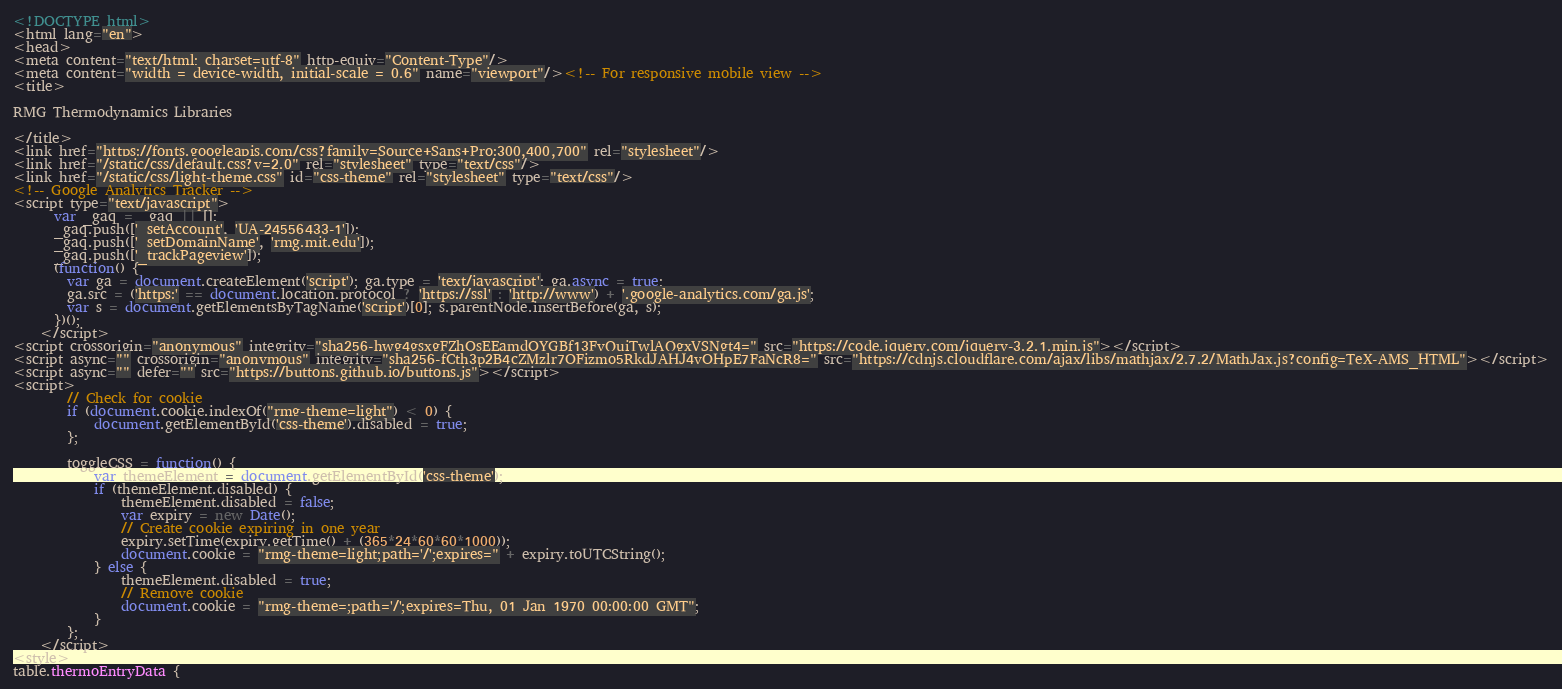<code> <loc_0><loc_0><loc_500><loc_500><_HTML_><!DOCTYPE html>
<html lang="en">
<head>
<meta content="text/html; charset=utf-8" http-equiv="Content-Type"/>
<meta content="width = device-width, initial-scale = 0.6" name="viewport"/><!-- For responsive mobile view -->
<title>

RMG Thermodynamics Libraries

</title>
<link href="https://fonts.googleapis.com/css?family=Source+Sans+Pro:300,400,700" rel="stylesheet"/>
<link href="/static/css/default.css?v=2.0" rel="stylesheet" type="text/css"/>
<link href="/static/css/light-theme.css" id="css-theme" rel="stylesheet" type="text/css"/>
<!-- Google Analytics Tracker -->
<script type="text/javascript">
      var _gaq = _gaq || [];
      _gaq.push(['_setAccount', 'UA-24556433-1']);
      _gaq.push(['_setDomainName', 'rmg.mit.edu']);
      _gaq.push(['_trackPageview']);
      (function() {
        var ga = document.createElement('script'); ga.type = 'text/javascript'; ga.async = true;
        ga.src = ('https:' == document.location.protocol ? 'https://ssl' : 'http://www') + '.google-analytics.com/ga.js';
        var s = document.getElementsByTagName('script')[0]; s.parentNode.insertBefore(ga, s);
      })();
    </script>
<script crossorigin="anonymous" integrity="sha256-hwg4gsxgFZhOsEEamdOYGBf13FyQuiTwlAQgxVSNgt4=" src="https://code.jquery.com/jquery-3.2.1.min.js"></script>
<script async="" crossorigin="anonymous" integrity="sha256-fCth3p2B4cZMzlr7OFizmo5RkdJAHJ4vOHpE7FaNcR8=" src="https://cdnjs.cloudflare.com/ajax/libs/mathjax/2.7.2/MathJax.js?config=TeX-AMS_HTML"></script>
<script async="" defer="" src="https://buttons.github.io/buttons.js"></script>
<script>
        // Check for cookie
        if (document.cookie.indexOf("rmg-theme=light") < 0) {
            document.getElementById('css-theme').disabled = true;
        };

        toggleCSS = function() {
            var themeElement = document.getElementById('css-theme');
            if (themeElement.disabled) {
                themeElement.disabled = false;
                var expiry = new Date();
                // Create cookie expiring in one year
                expiry.setTime(expiry.getTime() + (365*24*60*60*1000));
                document.cookie = "rmg-theme=light;path='/';expires=" + expiry.toUTCString();
            } else {
                themeElement.disabled = true;
                // Remove cookie
                document.cookie = "rmg-theme=;path='/';expires=Thu, 01 Jan 1970 00:00:00 GMT";
            }
        };
    </script>
<style>
table.thermoEntryData {</code> 